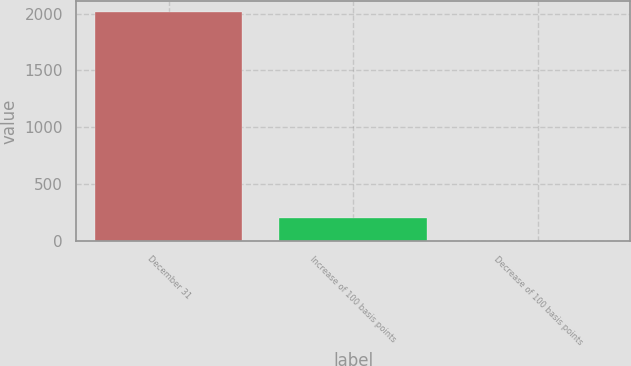<chart> <loc_0><loc_0><loc_500><loc_500><bar_chart><fcel>December 31<fcel>Increase of 100 basis points<fcel>Decrease of 100 basis points<nl><fcel>2013<fcel>205.35<fcel>4.5<nl></chart> 